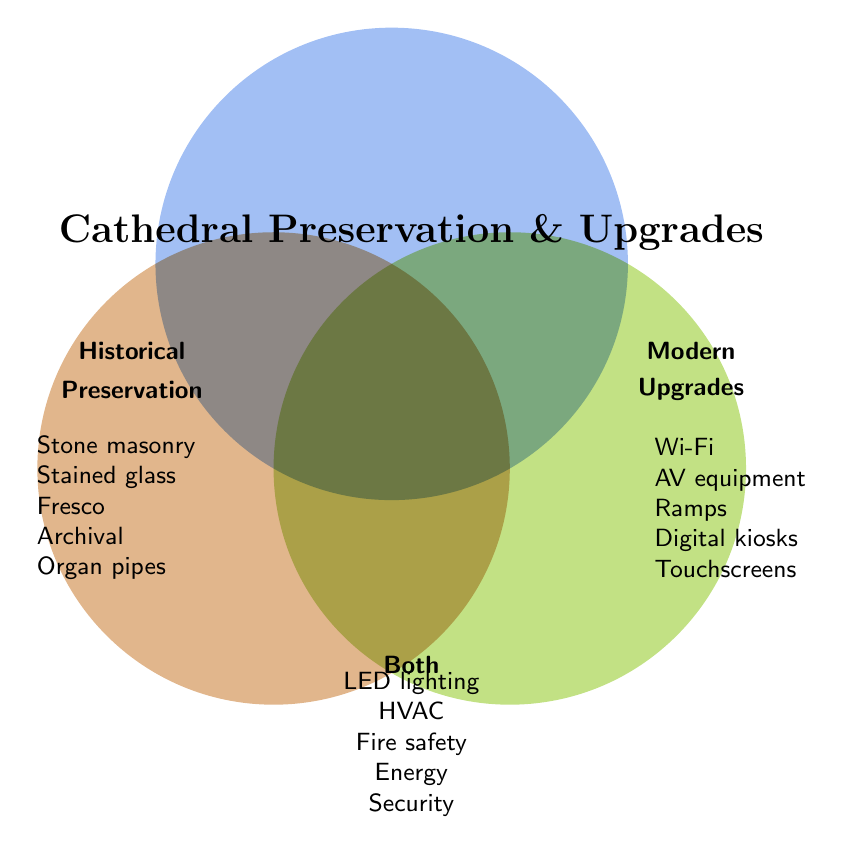What is the title of the Venn Diagram? The title is found at the top center of the Venn Diagram.
Answer: Cathedral Preservation & Upgrades What are the items listed under "Modern Upgrades"? The items are listed on the right side of the Venn Diagram under "Modern Upgrades". They are: Wi-Fi, AV equipment, Ramps, Digital kiosks, Touchscreens.
Answer: Wi-Fi, AV equipment, Ramps, Digital kiosks, Touchscreens Which items belong to both Historical Preservation and Modern Upgrades? The items shared between Historical Preservation and Modern Upgrades are listed in the overlapping section at the bottom center. These are: LED lighting, HVAC, Fire safety, Energy, Security.
Answer: LED lighting, HVAC, Fire safety, Energy, Security What items are related to accessibility in the Venn Diagram? We need to identify items related to accessibility in both Modern Upgrades and Both. Accessibility-related items are Ramps (Modern Upgrades) and potentially Energy, Security, and Fire safety (Both, indirectly related to building safety and usability).
Answer: Ramps, Energy, Security, Fire safety How many total categories include "Security"? First, check where "Security" is listed in the Venn Diagram. "Security" falls under the Both category. Only one category includes "Security".
Answer: 1 How many items are exclusive to Historical Preservation? Count the items listed under the "Historical Preservation" section. These are: Stone masonry, Stained glass restoration, Fresco conservation, Archival record keeping, Organ pipe maintenance. There are 5 items.
Answer: 5 Which area has more items, Modern Upgrades or both? Count the items in both sections. Modern Upgrades: 5 items (Wi-Fi, AV equipment, Ramps, Digital kiosks, Touchscreens). Both: 5 items (LED lighting, HVAC, Fire safety, Energy, Security). Both areas have an equal number of items.
Answer: Equal How many items are listed in total for the Venn Diagram? Sum the items in all three categories without counting duplicates. Historical: 5, Modern Upgrades: 5, Both: 5. Total = Historical + Modern - duplicated in Both = 5 + 5 + 5 = 15.
Answer: 15 